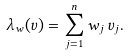Convert formula to latex. <formula><loc_0><loc_0><loc_500><loc_500>\lambda _ { w } ( v ) = \sum _ { j = 1 } ^ { n } w _ { j } \, v _ { j } .</formula> 